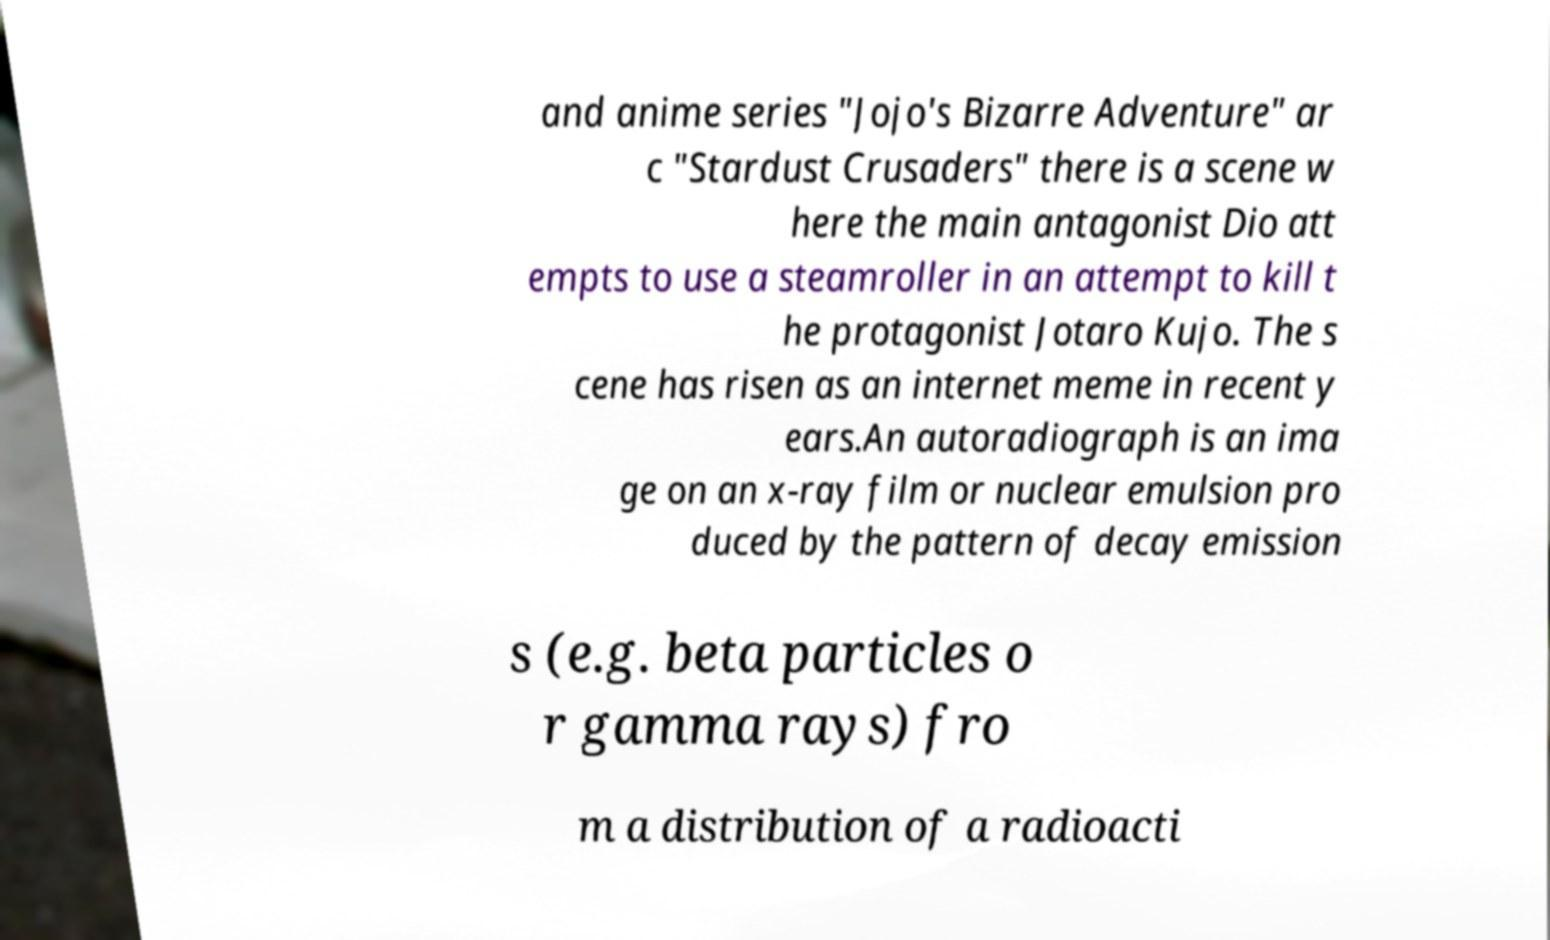What messages or text are displayed in this image? I need them in a readable, typed format. and anime series "Jojo's Bizarre Adventure" ar c "Stardust Crusaders" there is a scene w here the main antagonist Dio att empts to use a steamroller in an attempt to kill t he protagonist Jotaro Kujo. The s cene has risen as an internet meme in recent y ears.An autoradiograph is an ima ge on an x-ray film or nuclear emulsion pro duced by the pattern of decay emission s (e.g. beta particles o r gamma rays) fro m a distribution of a radioacti 